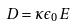<formula> <loc_0><loc_0><loc_500><loc_500>D = \kappa \epsilon _ { 0 } E</formula> 